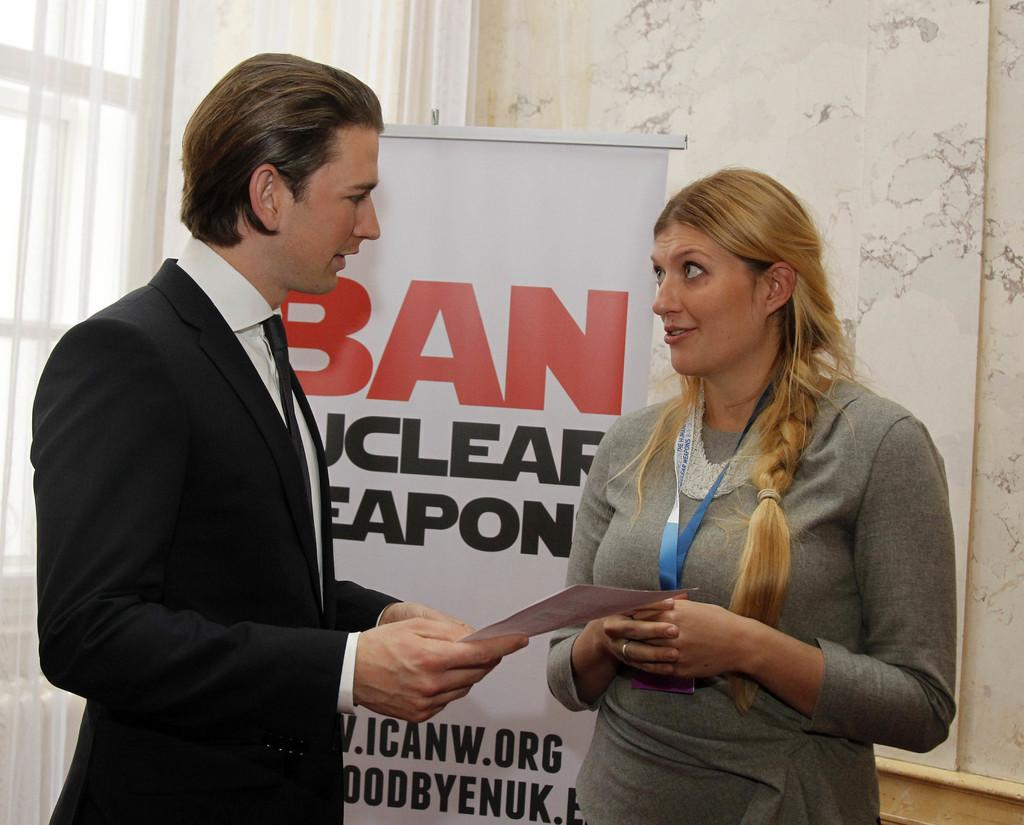How many people are present in the image? There are two persons in the image. What are the persons holding in their hands? The persons are holding paper. What can be seen in the background of the image? There is a whiteboard, a curtain associated with a window, the window, and a white wall visible in the background. What type of crown is the person wearing in the image? There is no crown present in the image; the persons are holding paper. What is the cannon used for in the image? There is no cannon present in the image. 